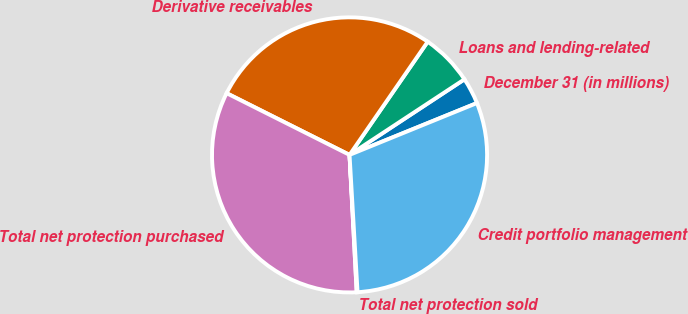Convert chart to OTSL. <chart><loc_0><loc_0><loc_500><loc_500><pie_chart><fcel>December 31 (in millions)<fcel>Loans and lending-related<fcel>Derivative receivables<fcel>Total net protection purchased<fcel>Total net protection sold<fcel>Credit portfolio management<nl><fcel>3.11%<fcel>6.12%<fcel>27.21%<fcel>33.23%<fcel>0.1%<fcel>30.22%<nl></chart> 